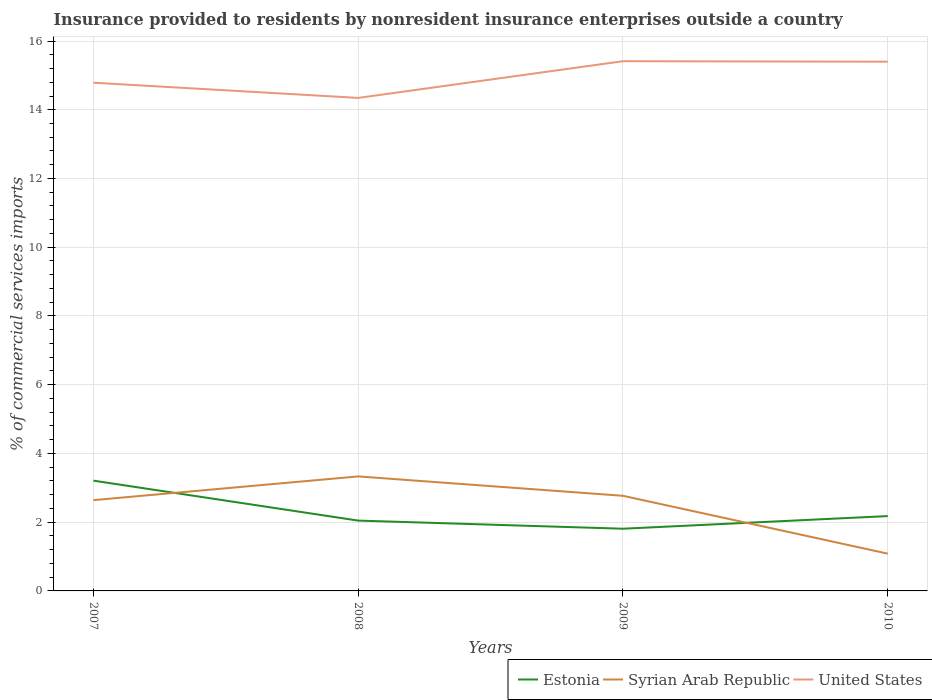Does the line corresponding to Estonia intersect with the line corresponding to United States?
Your answer should be compact. No. Across all years, what is the maximum Insurance provided to residents in United States?
Offer a terse response. 14.34. What is the total Insurance provided to residents in Estonia in the graph?
Provide a short and direct response. 1.03. What is the difference between the highest and the second highest Insurance provided to residents in United States?
Provide a short and direct response. 1.07. How many years are there in the graph?
Provide a succinct answer. 4. What is the difference between two consecutive major ticks on the Y-axis?
Keep it short and to the point. 2. Where does the legend appear in the graph?
Ensure brevity in your answer.  Bottom right. What is the title of the graph?
Offer a very short reply. Insurance provided to residents by nonresident insurance enterprises outside a country. Does "Singapore" appear as one of the legend labels in the graph?
Provide a succinct answer. No. What is the label or title of the Y-axis?
Provide a short and direct response. % of commercial services imports. What is the % of commercial services imports in Estonia in 2007?
Make the answer very short. 3.21. What is the % of commercial services imports in Syrian Arab Republic in 2007?
Provide a succinct answer. 2.64. What is the % of commercial services imports of United States in 2007?
Give a very brief answer. 14.79. What is the % of commercial services imports in Estonia in 2008?
Provide a short and direct response. 2.05. What is the % of commercial services imports in Syrian Arab Republic in 2008?
Provide a short and direct response. 3.33. What is the % of commercial services imports in United States in 2008?
Ensure brevity in your answer.  14.34. What is the % of commercial services imports of Estonia in 2009?
Offer a terse response. 1.81. What is the % of commercial services imports of Syrian Arab Republic in 2009?
Give a very brief answer. 2.77. What is the % of commercial services imports of United States in 2009?
Offer a terse response. 15.41. What is the % of commercial services imports in Estonia in 2010?
Make the answer very short. 2.18. What is the % of commercial services imports in Syrian Arab Republic in 2010?
Keep it short and to the point. 1.08. What is the % of commercial services imports in United States in 2010?
Provide a short and direct response. 15.4. Across all years, what is the maximum % of commercial services imports of Estonia?
Give a very brief answer. 3.21. Across all years, what is the maximum % of commercial services imports in Syrian Arab Republic?
Keep it short and to the point. 3.33. Across all years, what is the maximum % of commercial services imports of United States?
Offer a very short reply. 15.41. Across all years, what is the minimum % of commercial services imports of Estonia?
Offer a very short reply. 1.81. Across all years, what is the minimum % of commercial services imports of Syrian Arab Republic?
Your response must be concise. 1.08. Across all years, what is the minimum % of commercial services imports of United States?
Your answer should be compact. 14.34. What is the total % of commercial services imports in Estonia in the graph?
Provide a succinct answer. 9.24. What is the total % of commercial services imports of Syrian Arab Republic in the graph?
Your answer should be very brief. 9.82. What is the total % of commercial services imports in United States in the graph?
Provide a short and direct response. 59.94. What is the difference between the % of commercial services imports in Estonia in 2007 and that in 2008?
Offer a very short reply. 1.16. What is the difference between the % of commercial services imports of Syrian Arab Republic in 2007 and that in 2008?
Offer a terse response. -0.69. What is the difference between the % of commercial services imports of United States in 2007 and that in 2008?
Give a very brief answer. 0.44. What is the difference between the % of commercial services imports in Estonia in 2007 and that in 2009?
Provide a succinct answer. 1.4. What is the difference between the % of commercial services imports of Syrian Arab Republic in 2007 and that in 2009?
Make the answer very short. -0.13. What is the difference between the % of commercial services imports in United States in 2007 and that in 2009?
Your answer should be compact. -0.63. What is the difference between the % of commercial services imports of Estonia in 2007 and that in 2010?
Provide a succinct answer. 1.03. What is the difference between the % of commercial services imports in Syrian Arab Republic in 2007 and that in 2010?
Keep it short and to the point. 1.56. What is the difference between the % of commercial services imports of United States in 2007 and that in 2010?
Offer a terse response. -0.61. What is the difference between the % of commercial services imports of Estonia in 2008 and that in 2009?
Ensure brevity in your answer.  0.24. What is the difference between the % of commercial services imports of Syrian Arab Republic in 2008 and that in 2009?
Your answer should be compact. 0.56. What is the difference between the % of commercial services imports of United States in 2008 and that in 2009?
Offer a very short reply. -1.07. What is the difference between the % of commercial services imports of Estonia in 2008 and that in 2010?
Your response must be concise. -0.13. What is the difference between the % of commercial services imports in Syrian Arab Republic in 2008 and that in 2010?
Ensure brevity in your answer.  2.25. What is the difference between the % of commercial services imports in United States in 2008 and that in 2010?
Give a very brief answer. -1.05. What is the difference between the % of commercial services imports of Estonia in 2009 and that in 2010?
Ensure brevity in your answer.  -0.37. What is the difference between the % of commercial services imports of Syrian Arab Republic in 2009 and that in 2010?
Offer a terse response. 1.68. What is the difference between the % of commercial services imports in United States in 2009 and that in 2010?
Ensure brevity in your answer.  0.01. What is the difference between the % of commercial services imports in Estonia in 2007 and the % of commercial services imports in Syrian Arab Republic in 2008?
Your answer should be very brief. -0.12. What is the difference between the % of commercial services imports of Estonia in 2007 and the % of commercial services imports of United States in 2008?
Your response must be concise. -11.14. What is the difference between the % of commercial services imports of Syrian Arab Republic in 2007 and the % of commercial services imports of United States in 2008?
Offer a terse response. -11.7. What is the difference between the % of commercial services imports of Estonia in 2007 and the % of commercial services imports of Syrian Arab Republic in 2009?
Ensure brevity in your answer.  0.44. What is the difference between the % of commercial services imports in Estonia in 2007 and the % of commercial services imports in United States in 2009?
Your answer should be very brief. -12.2. What is the difference between the % of commercial services imports of Syrian Arab Republic in 2007 and the % of commercial services imports of United States in 2009?
Provide a short and direct response. -12.77. What is the difference between the % of commercial services imports of Estonia in 2007 and the % of commercial services imports of Syrian Arab Republic in 2010?
Give a very brief answer. 2.12. What is the difference between the % of commercial services imports of Estonia in 2007 and the % of commercial services imports of United States in 2010?
Offer a very short reply. -12.19. What is the difference between the % of commercial services imports in Syrian Arab Republic in 2007 and the % of commercial services imports in United States in 2010?
Make the answer very short. -12.76. What is the difference between the % of commercial services imports of Estonia in 2008 and the % of commercial services imports of Syrian Arab Republic in 2009?
Give a very brief answer. -0.72. What is the difference between the % of commercial services imports of Estonia in 2008 and the % of commercial services imports of United States in 2009?
Keep it short and to the point. -13.37. What is the difference between the % of commercial services imports of Syrian Arab Republic in 2008 and the % of commercial services imports of United States in 2009?
Your answer should be compact. -12.08. What is the difference between the % of commercial services imports of Estonia in 2008 and the % of commercial services imports of Syrian Arab Republic in 2010?
Offer a very short reply. 0.96. What is the difference between the % of commercial services imports of Estonia in 2008 and the % of commercial services imports of United States in 2010?
Your response must be concise. -13.35. What is the difference between the % of commercial services imports of Syrian Arab Republic in 2008 and the % of commercial services imports of United States in 2010?
Make the answer very short. -12.07. What is the difference between the % of commercial services imports in Estonia in 2009 and the % of commercial services imports in Syrian Arab Republic in 2010?
Your response must be concise. 0.73. What is the difference between the % of commercial services imports of Estonia in 2009 and the % of commercial services imports of United States in 2010?
Offer a terse response. -13.59. What is the difference between the % of commercial services imports in Syrian Arab Republic in 2009 and the % of commercial services imports in United States in 2010?
Your answer should be very brief. -12.63. What is the average % of commercial services imports in Estonia per year?
Give a very brief answer. 2.31. What is the average % of commercial services imports in Syrian Arab Republic per year?
Give a very brief answer. 2.46. What is the average % of commercial services imports in United States per year?
Give a very brief answer. 14.99. In the year 2007, what is the difference between the % of commercial services imports of Estonia and % of commercial services imports of Syrian Arab Republic?
Your answer should be very brief. 0.57. In the year 2007, what is the difference between the % of commercial services imports in Estonia and % of commercial services imports in United States?
Keep it short and to the point. -11.58. In the year 2007, what is the difference between the % of commercial services imports of Syrian Arab Republic and % of commercial services imports of United States?
Give a very brief answer. -12.15. In the year 2008, what is the difference between the % of commercial services imports in Estonia and % of commercial services imports in Syrian Arab Republic?
Make the answer very short. -1.29. In the year 2008, what is the difference between the % of commercial services imports of Estonia and % of commercial services imports of United States?
Give a very brief answer. -12.3. In the year 2008, what is the difference between the % of commercial services imports of Syrian Arab Republic and % of commercial services imports of United States?
Provide a succinct answer. -11.01. In the year 2009, what is the difference between the % of commercial services imports in Estonia and % of commercial services imports in Syrian Arab Republic?
Provide a short and direct response. -0.96. In the year 2009, what is the difference between the % of commercial services imports of Estonia and % of commercial services imports of United States?
Give a very brief answer. -13.6. In the year 2009, what is the difference between the % of commercial services imports of Syrian Arab Republic and % of commercial services imports of United States?
Offer a very short reply. -12.65. In the year 2010, what is the difference between the % of commercial services imports in Estonia and % of commercial services imports in Syrian Arab Republic?
Your answer should be very brief. 1.09. In the year 2010, what is the difference between the % of commercial services imports in Estonia and % of commercial services imports in United States?
Offer a terse response. -13.22. In the year 2010, what is the difference between the % of commercial services imports of Syrian Arab Republic and % of commercial services imports of United States?
Provide a short and direct response. -14.31. What is the ratio of the % of commercial services imports in Estonia in 2007 to that in 2008?
Provide a succinct answer. 1.57. What is the ratio of the % of commercial services imports in Syrian Arab Republic in 2007 to that in 2008?
Provide a succinct answer. 0.79. What is the ratio of the % of commercial services imports of United States in 2007 to that in 2008?
Your answer should be very brief. 1.03. What is the ratio of the % of commercial services imports in Estonia in 2007 to that in 2009?
Make the answer very short. 1.77. What is the ratio of the % of commercial services imports in Syrian Arab Republic in 2007 to that in 2009?
Make the answer very short. 0.95. What is the ratio of the % of commercial services imports in United States in 2007 to that in 2009?
Your answer should be compact. 0.96. What is the ratio of the % of commercial services imports in Estonia in 2007 to that in 2010?
Your answer should be very brief. 1.47. What is the ratio of the % of commercial services imports in Syrian Arab Republic in 2007 to that in 2010?
Your response must be concise. 2.44. What is the ratio of the % of commercial services imports in United States in 2007 to that in 2010?
Keep it short and to the point. 0.96. What is the ratio of the % of commercial services imports of Estonia in 2008 to that in 2009?
Keep it short and to the point. 1.13. What is the ratio of the % of commercial services imports in Syrian Arab Republic in 2008 to that in 2009?
Ensure brevity in your answer.  1.2. What is the ratio of the % of commercial services imports in United States in 2008 to that in 2009?
Offer a terse response. 0.93. What is the ratio of the % of commercial services imports of Estonia in 2008 to that in 2010?
Your answer should be compact. 0.94. What is the ratio of the % of commercial services imports in Syrian Arab Republic in 2008 to that in 2010?
Offer a terse response. 3.07. What is the ratio of the % of commercial services imports in United States in 2008 to that in 2010?
Offer a very short reply. 0.93. What is the ratio of the % of commercial services imports of Estonia in 2009 to that in 2010?
Offer a terse response. 0.83. What is the ratio of the % of commercial services imports of Syrian Arab Republic in 2009 to that in 2010?
Your response must be concise. 2.55. What is the ratio of the % of commercial services imports of United States in 2009 to that in 2010?
Make the answer very short. 1. What is the difference between the highest and the second highest % of commercial services imports in Estonia?
Ensure brevity in your answer.  1.03. What is the difference between the highest and the second highest % of commercial services imports in Syrian Arab Republic?
Your answer should be compact. 0.56. What is the difference between the highest and the second highest % of commercial services imports in United States?
Your answer should be compact. 0.01. What is the difference between the highest and the lowest % of commercial services imports of Estonia?
Ensure brevity in your answer.  1.4. What is the difference between the highest and the lowest % of commercial services imports in Syrian Arab Republic?
Provide a succinct answer. 2.25. What is the difference between the highest and the lowest % of commercial services imports in United States?
Keep it short and to the point. 1.07. 